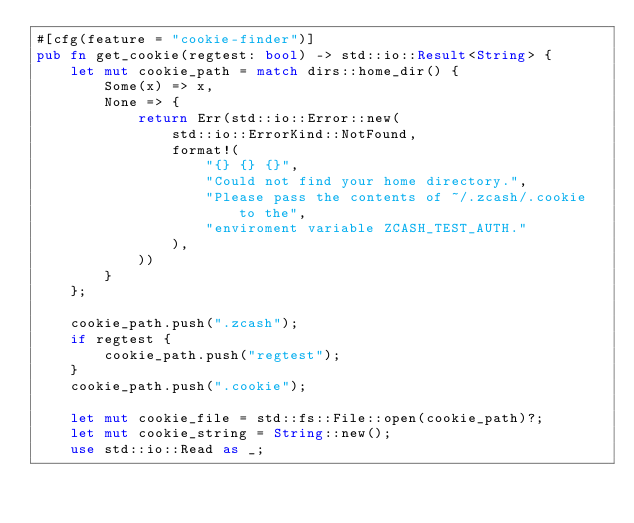Convert code to text. <code><loc_0><loc_0><loc_500><loc_500><_Rust_>#[cfg(feature = "cookie-finder")]
pub fn get_cookie(regtest: bool) -> std::io::Result<String> {
    let mut cookie_path = match dirs::home_dir() {
        Some(x) => x,
        None => {
            return Err(std::io::Error::new(
                std::io::ErrorKind::NotFound,
                format!(
                    "{} {} {}",
                    "Could not find your home directory.",
                    "Please pass the contents of ~/.zcash/.cookie to the",
                    "enviroment variable ZCASH_TEST_AUTH."
                ),
            ))
        }
    };

    cookie_path.push(".zcash");
    if regtest {
        cookie_path.push("regtest");
    }
    cookie_path.push(".cookie");

    let mut cookie_file = std::fs::File::open(cookie_path)?;
    let mut cookie_string = String::new();
    use std::io::Read as _;</code> 